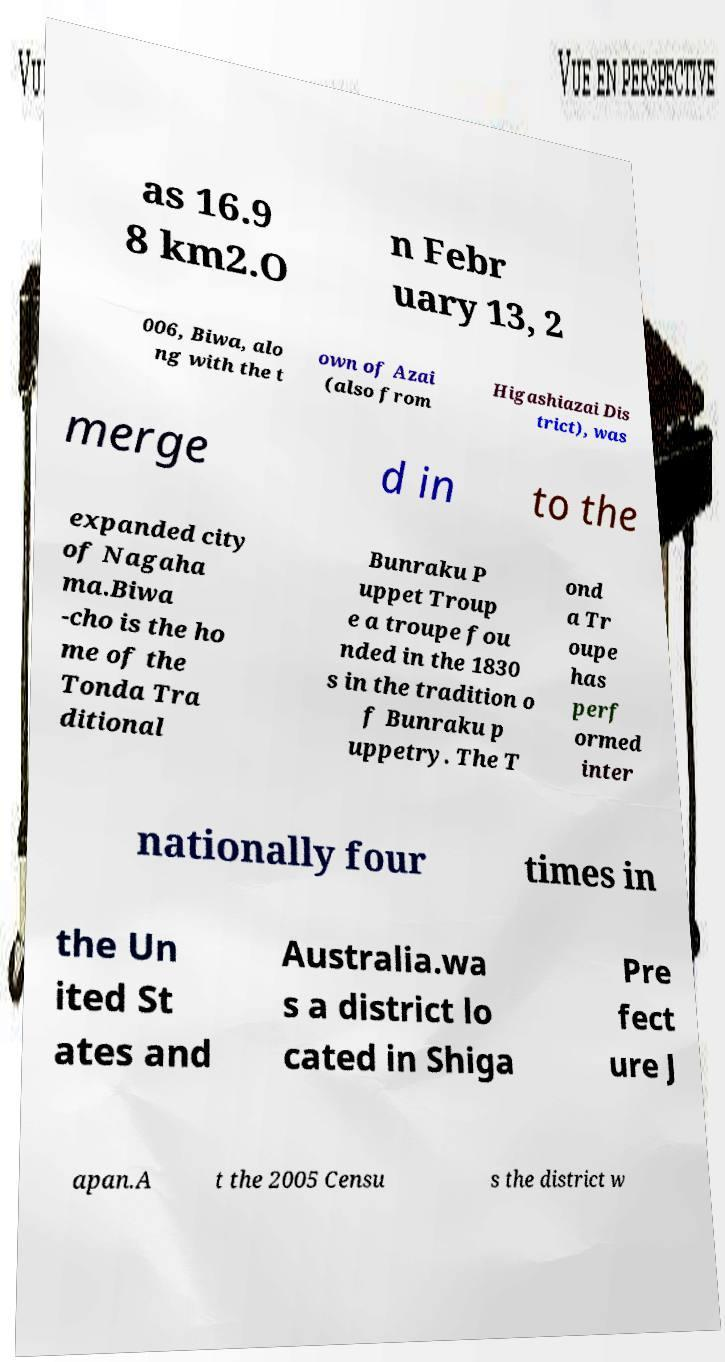What messages or text are displayed in this image? I need them in a readable, typed format. as 16.9 8 km2.O n Febr uary 13, 2 006, Biwa, alo ng with the t own of Azai (also from Higashiazai Dis trict), was merge d in to the expanded city of Nagaha ma.Biwa -cho is the ho me of the Tonda Tra ditional Bunraku P uppet Troup e a troupe fou nded in the 1830 s in the tradition o f Bunraku p uppetry. The T ond a Tr oupe has perf ormed inter nationally four times in the Un ited St ates and Australia.wa s a district lo cated in Shiga Pre fect ure J apan.A t the 2005 Censu s the district w 